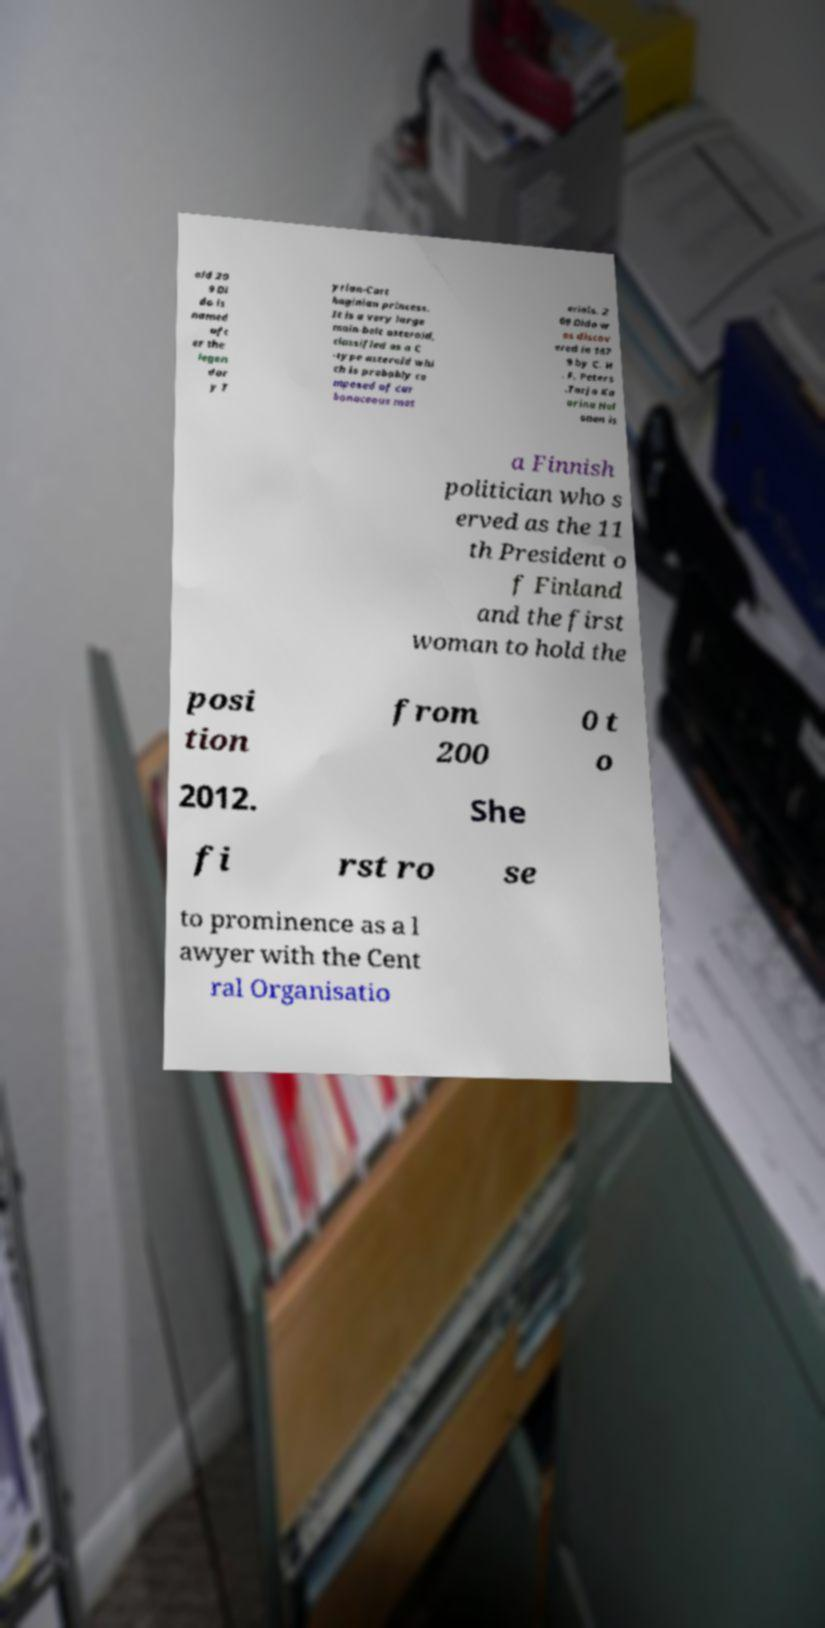I need the written content from this picture converted into text. Can you do that? oid 20 9 Di do is named aft er the legen dar y T yrian-Cart haginian princess. It is a very large main-belt asteroid, classified as a C -type asteroid whi ch is probably co mposed of car bonaceous mat erials. 2 09 Dido w as discov ered in 187 9 by C. H . F. Peters .Tarja Ka arina Hal onen is a Finnish politician who s erved as the 11 th President o f Finland and the first woman to hold the posi tion from 200 0 t o 2012. She fi rst ro se to prominence as a l awyer with the Cent ral Organisatio 